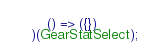Convert code to text. <code><loc_0><loc_0><loc_500><loc_500><_JavaScript_>	() => ({})
)(GearStatSelect);
</code> 